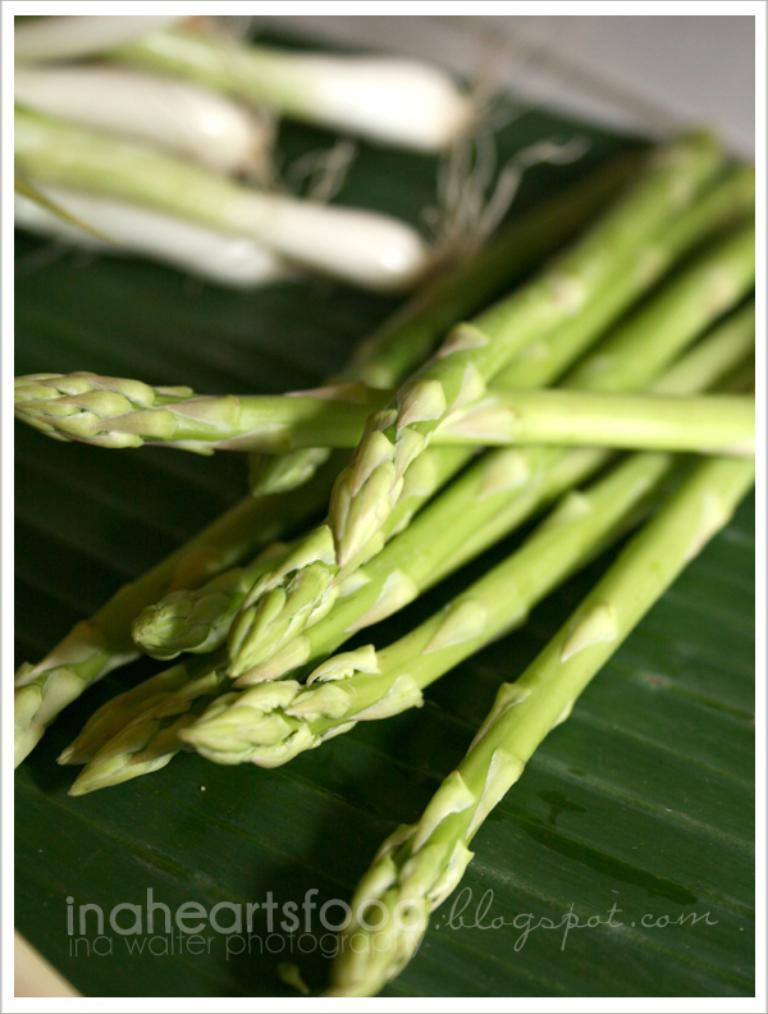What color are the objects in the front of the image? The objects in the front of the image are green. Can you describe the position of these green objects in the image? The green objects are in the front of the image. Is there any additional information about the image itself? Yes, there is a watermark on the bottom side of the image. Is the queen standing in the quicksand in the image? There is no queen or quicksand present in the image. 